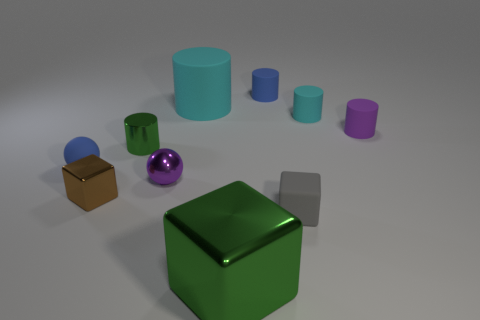Subtract all green cylinders. How many cylinders are left? 4 Subtract all small shiny cylinders. How many cylinders are left? 4 Subtract all purple cylinders. Subtract all yellow balls. How many cylinders are left? 4 Subtract all spheres. How many objects are left? 8 Add 5 tiny green metal cylinders. How many tiny green metal cylinders are left? 6 Add 2 gray metallic balls. How many gray metallic balls exist? 2 Subtract 0 blue cubes. How many objects are left? 10 Subtract all blue rubber spheres. Subtract all large green rubber blocks. How many objects are left? 9 